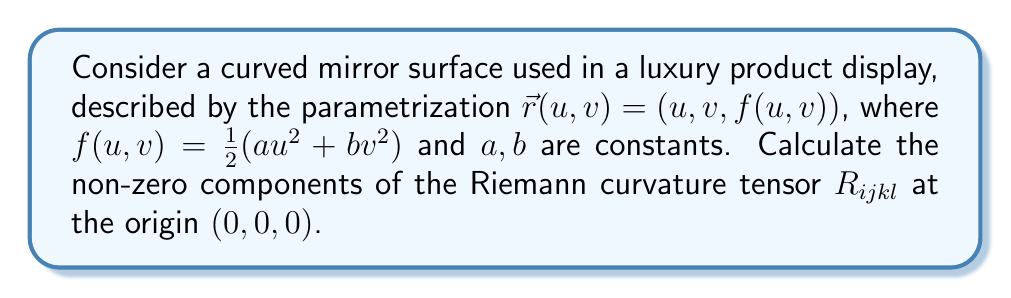Can you answer this question? To calculate the Riemann curvature tensor, we'll follow these steps:

1) First, we need to calculate the metric tensor $g_{ij}$:
   $$g_{ij} = \frac{\partial \vec{r}}{\partial x^i} \cdot \frac{\partial \vec{r}}{\partial x^j}$$
   
   $\frac{\partial \vec{r}}{\partial u} = (1, 0, au)$
   $\frac{\partial \vec{r}}{\partial v} = (0, 1, bv)$
   
   At the origin:
   $g_{11} = 1 + (au)^2 = 1$
   $g_{22} = 1 + (bv)^2 = 1$
   $g_{12} = g_{21} = 0$

2) Next, we calculate the Christoffel symbols:
   $$\Gamma^k_{ij} = \frac{1}{2}g^{kl}(\frac{\partial g_{il}}{\partial x^j} + \frac{\partial g_{jl}}{\partial x^i} - \frac{\partial g_{ij}}{\partial x^l})$$
   
   At the origin, the only non-zero Christoffel symbols are:
   $\Gamma^3_{11} = a$
   $\Gamma^3_{22} = b$

3) Now we can calculate the Riemann curvature tensor:
   $$R^i_{jkl} = \frac{\partial \Gamma^i_{jl}}{\partial x^k} - \frac{\partial \Gamma^i_{jk}}{\partial x^l} + \Gamma^m_{jl}\Gamma^i_{mk} - \Gamma^m_{jk}\Gamma^i_{ml}$$

   The only non-zero components are:
   $R^3_{131} = -\frac{\partial \Gamma^3_{11}}{\partial x^3} = -a$
   $R^3_{232} = -\frac{\partial \Gamma^3_{22}}{\partial x^3} = -b$

4) Finally, we lower the first index to get $R_{ijkl}$:
   $R_{1313} = g_{13}R^3_{131} = -a$
   $R_{2323} = g_{23}R^3_{232} = -b$

   Due to the symmetries of the Riemann tensor, we also have:
   $R_{3131} = R_{1313} = -a$
   $R_{3232} = R_{2323} = -b$
Answer: $R_{1313} = R_{3131} = -a$, $R_{2323} = R_{3232} = -b$ 